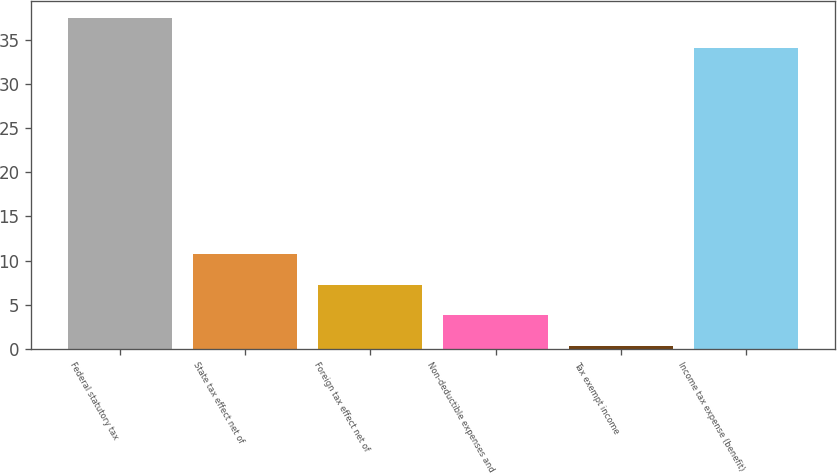Convert chart to OTSL. <chart><loc_0><loc_0><loc_500><loc_500><bar_chart><fcel>Federal statutory tax<fcel>State tax effect net of<fcel>Foreign tax effect net of<fcel>Non-deductible expenses and<fcel>Tax exempt income<fcel>Income tax expense (benefit)<nl><fcel>37.57<fcel>10.71<fcel>7.24<fcel>3.77<fcel>0.3<fcel>34.1<nl></chart> 